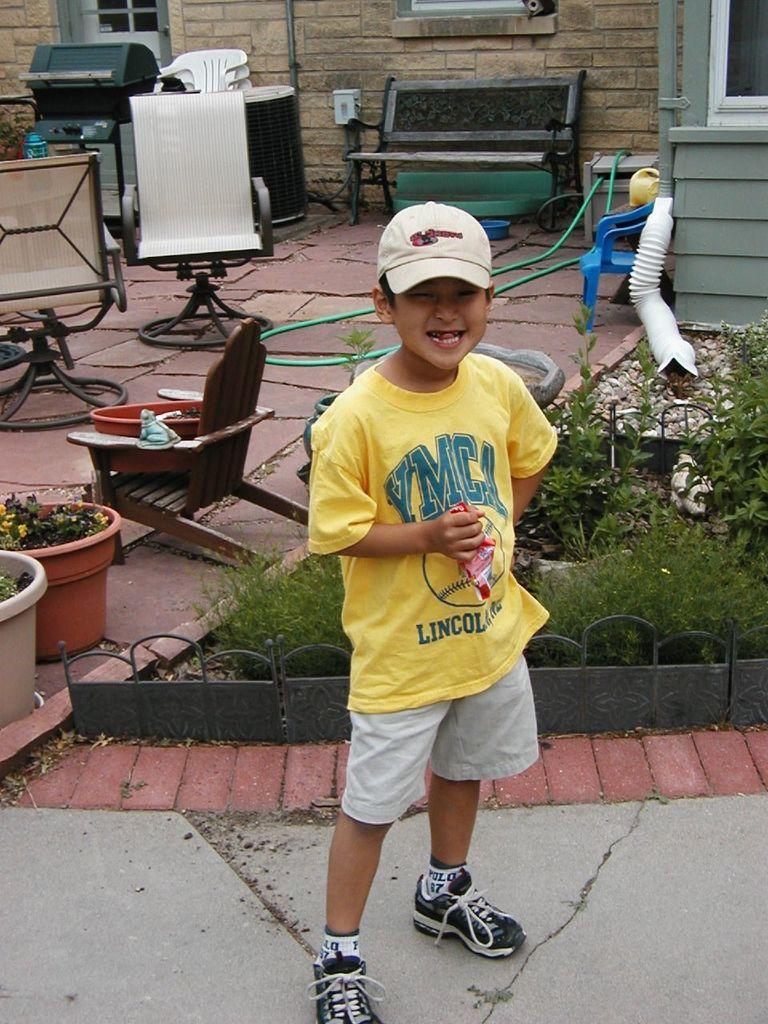Please provide a concise description of this image. In the image we can see a child wearing clothes, shoes, the cap and the child is smiling, the child is holding an object in hand. Here we can see the grass, pots and chairs. Here we can see the pipe and it look like the building. 